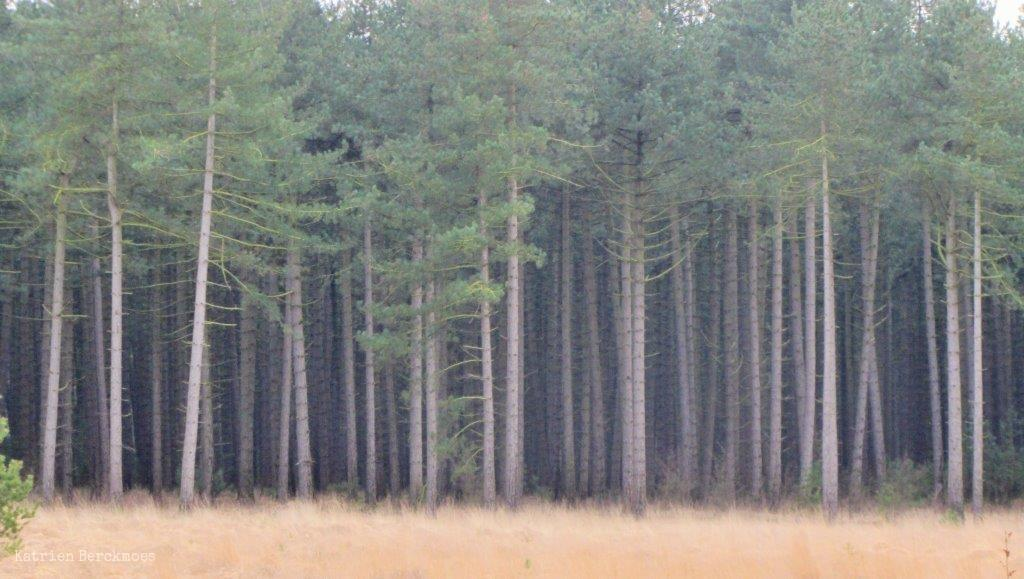What is located in the center of the image? There are trees, plants, and grass in the center of the image. Can you describe the vegetation in the image? The image features trees, plants, and grass. Is there any text or marking on the image? Yes, there is a watermark on the bottom left of the image. What type of arm can be seen reaching for the grass in the image? There is no arm or person present in the image; it only features trees, plants, grass, and a watermark. How many pigs are visible in the image? There are no pigs present in the image. 